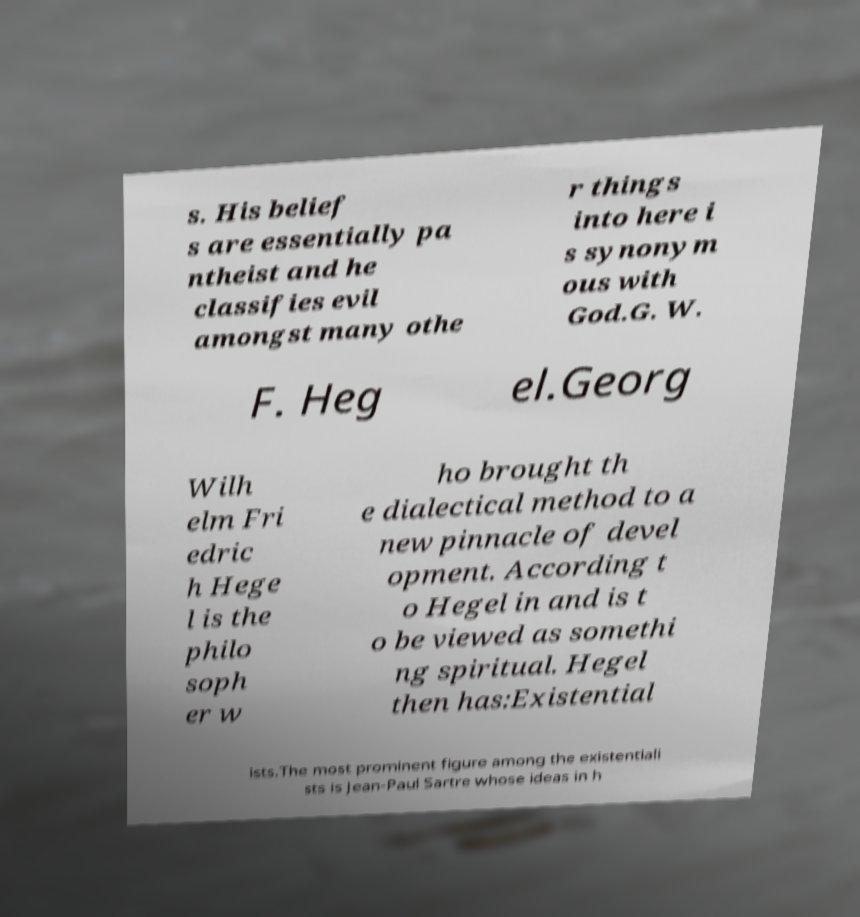Can you read and provide the text displayed in the image?This photo seems to have some interesting text. Can you extract and type it out for me? s. His belief s are essentially pa ntheist and he classifies evil amongst many othe r things into here i s synonym ous with God.G. W. F. Heg el.Georg Wilh elm Fri edric h Hege l is the philo soph er w ho brought th e dialectical method to a new pinnacle of devel opment. According t o Hegel in and is t o be viewed as somethi ng spiritual. Hegel then has:Existential ists.The most prominent figure among the existentiali sts is Jean-Paul Sartre whose ideas in h 